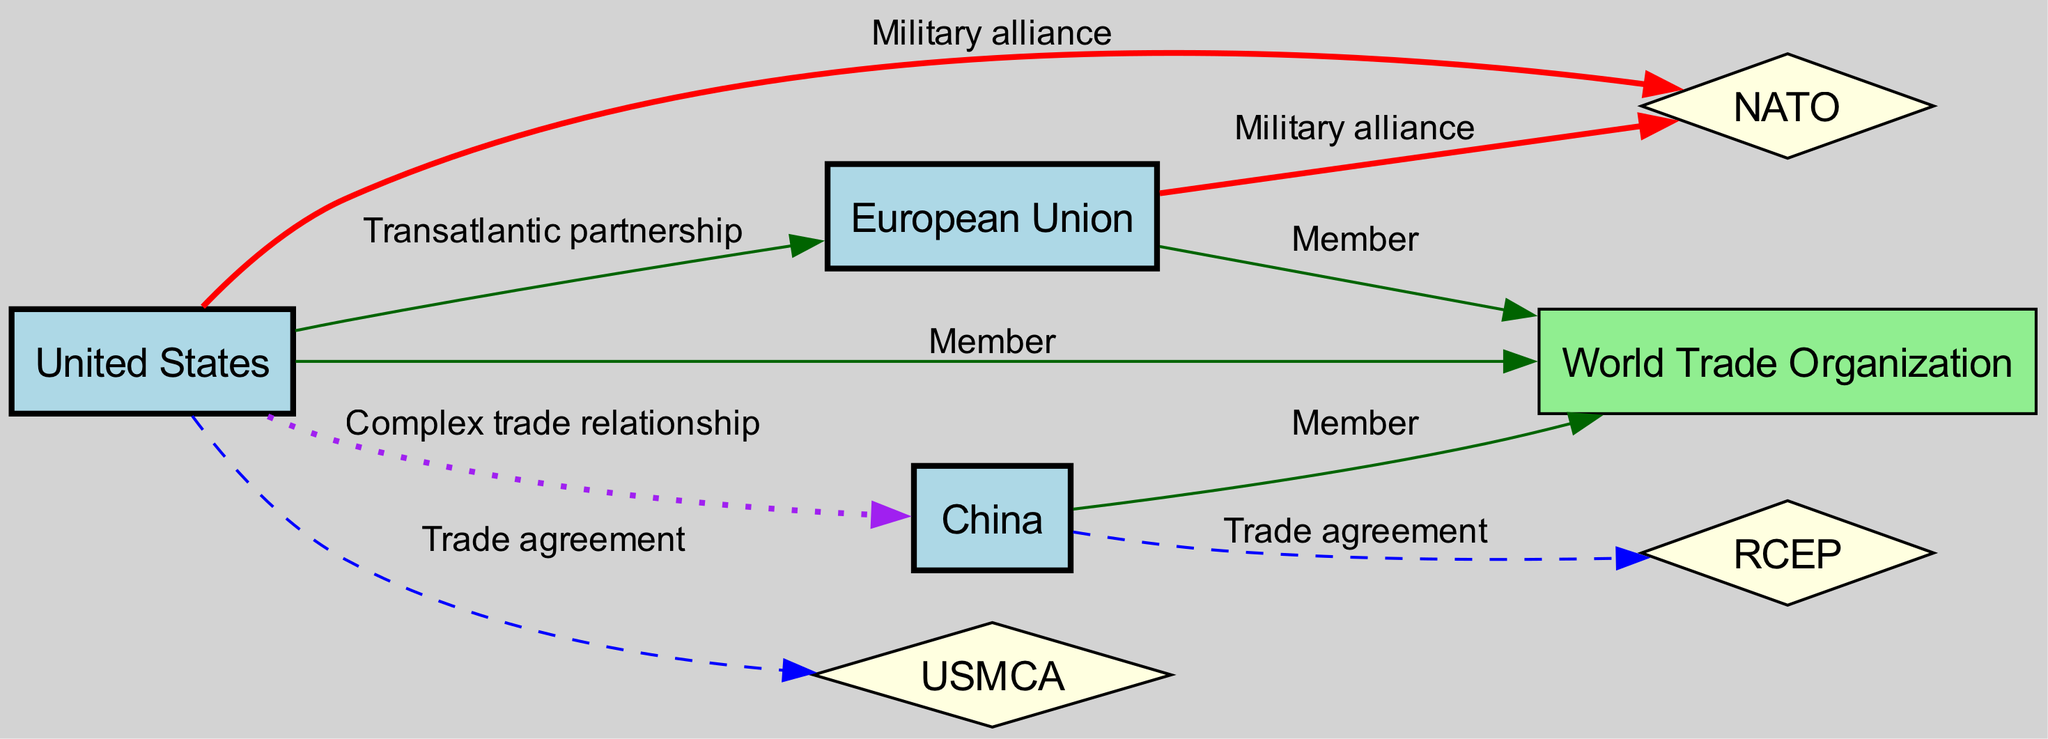What are the three main nodes in this diagram? The main nodes listed in the diagram are the United States, European Union, and China, as they are the only nodes depicted without a special shape. These nodes represent dominant players in international relations.
Answer: United States, European Union, China How many trade agreements are shown in the diagram? The diagram shows two trade agreements: USMCA and RCEP. To identify them, one must count the edges labeled 'Trade agreement' which connect respective nodes.
Answer: 2 Which organization is a member of both the United States and European Union? The World Trade Organization is illustrated as a member of both the United States and European Union, as indicated by the connecting edges to these nodes without any additional descriptors.
Answer: World Trade Organization What type of relationship exists between the USA and China? The relationship between the USA and China is labeled as a 'Complex trade relationship,' which is depicted by the distinctly styled edge connecting the two nodes.
Answer: Complex trade relationship How many military alliances are shown in the diagram? There are two military alliances represented in the diagram: NATO, which connects to both the USA and EU. By counting the edges labeled 'Military alliance,' we find this total.
Answer: 2 Which two nodes are connected by a transatlantic partnership? The edge indicating a transatlantic partnership connects the United States to the European Union as labeled in the diagram. The wording directly identifies the relationship described.
Answer: United States, European Union What is the shape of the nodes representing trade agreements? The trade agreement nodes are depicted as diamonds in the diagram. This is a distinguishing characteristic specific to the types of agreements mentioned.
Answer: Diamond Which node has the most connections? The United States has the most connections. By reviewing the edges, we assess that the USA is connected to NATO, USMCA, EU, China, and WTO—five edges in total.
Answer: United States 